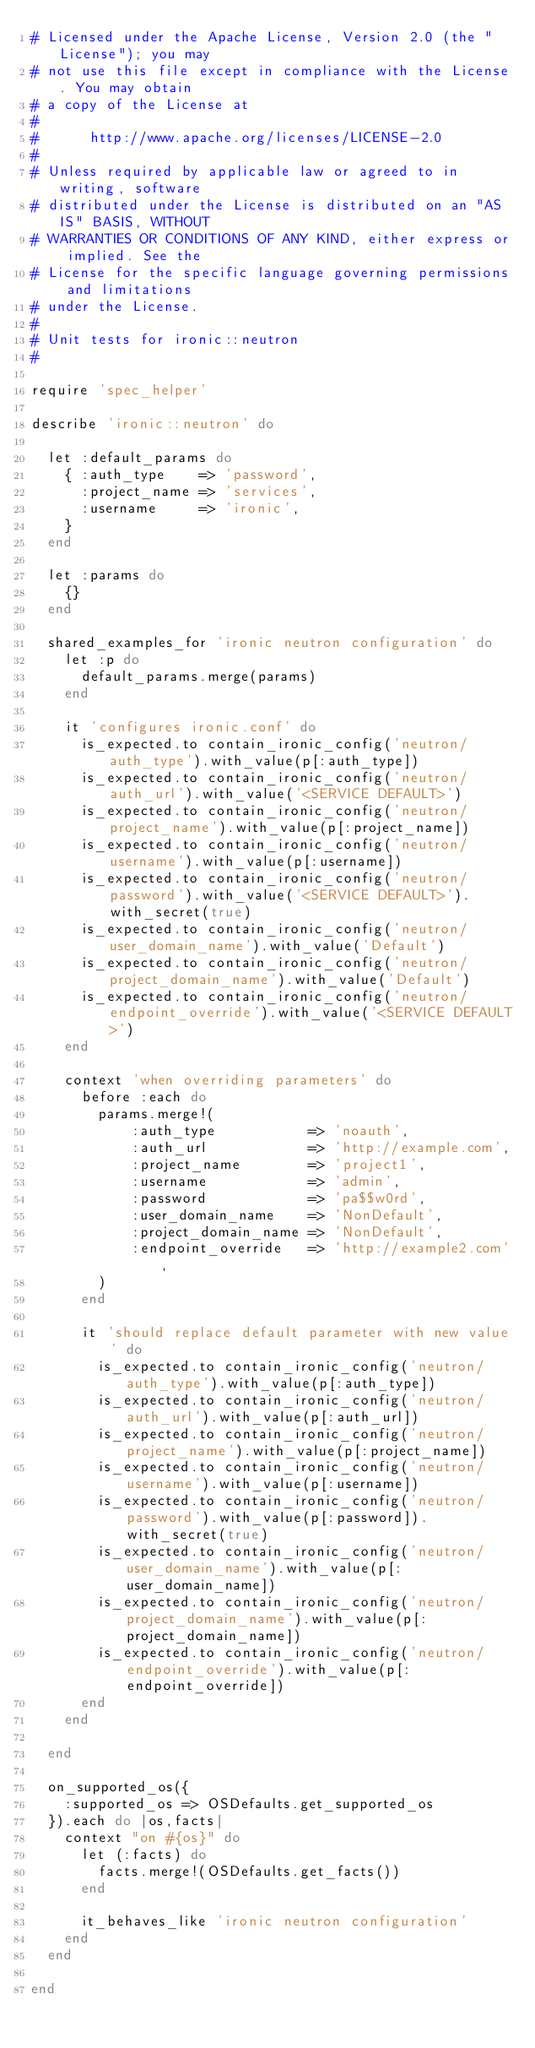<code> <loc_0><loc_0><loc_500><loc_500><_Ruby_># Licensed under the Apache License, Version 2.0 (the "License"); you may
# not use this file except in compliance with the License. You may obtain
# a copy of the License at
#
#      http://www.apache.org/licenses/LICENSE-2.0
#
# Unless required by applicable law or agreed to in writing, software
# distributed under the License is distributed on an "AS IS" BASIS, WITHOUT
# WARRANTIES OR CONDITIONS OF ANY KIND, either express or implied. See the
# License for the specific language governing permissions and limitations
# under the License.
#
# Unit tests for ironic::neutron
#

require 'spec_helper'

describe 'ironic::neutron' do

  let :default_params do
    { :auth_type    => 'password',
      :project_name => 'services',
      :username     => 'ironic',
    }
  end

  let :params do
    {}
  end

  shared_examples_for 'ironic neutron configuration' do
    let :p do
      default_params.merge(params)
    end

    it 'configures ironic.conf' do
      is_expected.to contain_ironic_config('neutron/auth_type').with_value(p[:auth_type])
      is_expected.to contain_ironic_config('neutron/auth_url').with_value('<SERVICE DEFAULT>')
      is_expected.to contain_ironic_config('neutron/project_name').with_value(p[:project_name])
      is_expected.to contain_ironic_config('neutron/username').with_value(p[:username])
      is_expected.to contain_ironic_config('neutron/password').with_value('<SERVICE DEFAULT>').with_secret(true)
      is_expected.to contain_ironic_config('neutron/user_domain_name').with_value('Default')
      is_expected.to contain_ironic_config('neutron/project_domain_name').with_value('Default')
      is_expected.to contain_ironic_config('neutron/endpoint_override').with_value('<SERVICE DEFAULT>')
    end

    context 'when overriding parameters' do
      before :each do
        params.merge!(
            :auth_type           => 'noauth',
            :auth_url            => 'http://example.com',
            :project_name        => 'project1',
            :username            => 'admin',
            :password            => 'pa$$w0rd',
            :user_domain_name    => 'NonDefault',
            :project_domain_name => 'NonDefault',
            :endpoint_override   => 'http://example2.com',
        )
      end

      it 'should replace default parameter with new value' do
        is_expected.to contain_ironic_config('neutron/auth_type').with_value(p[:auth_type])
        is_expected.to contain_ironic_config('neutron/auth_url').with_value(p[:auth_url])
        is_expected.to contain_ironic_config('neutron/project_name').with_value(p[:project_name])
        is_expected.to contain_ironic_config('neutron/username').with_value(p[:username])
        is_expected.to contain_ironic_config('neutron/password').with_value(p[:password]).with_secret(true)
        is_expected.to contain_ironic_config('neutron/user_domain_name').with_value(p[:user_domain_name])
        is_expected.to contain_ironic_config('neutron/project_domain_name').with_value(p[:project_domain_name])
        is_expected.to contain_ironic_config('neutron/endpoint_override').with_value(p[:endpoint_override])
      end
    end

  end

  on_supported_os({
    :supported_os => OSDefaults.get_supported_os
  }).each do |os,facts|
    context "on #{os}" do
      let (:facts) do
        facts.merge!(OSDefaults.get_facts())
      end

      it_behaves_like 'ironic neutron configuration'
    end
  end

end
</code> 